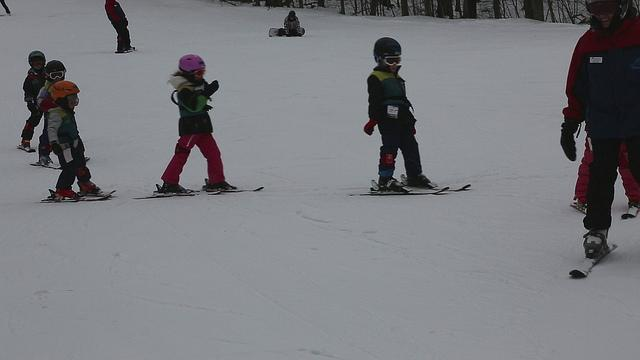What sort of lesson might the short people be getting? Please explain your reasoning. beginner ski. Learning to ski starts by not using poles. 